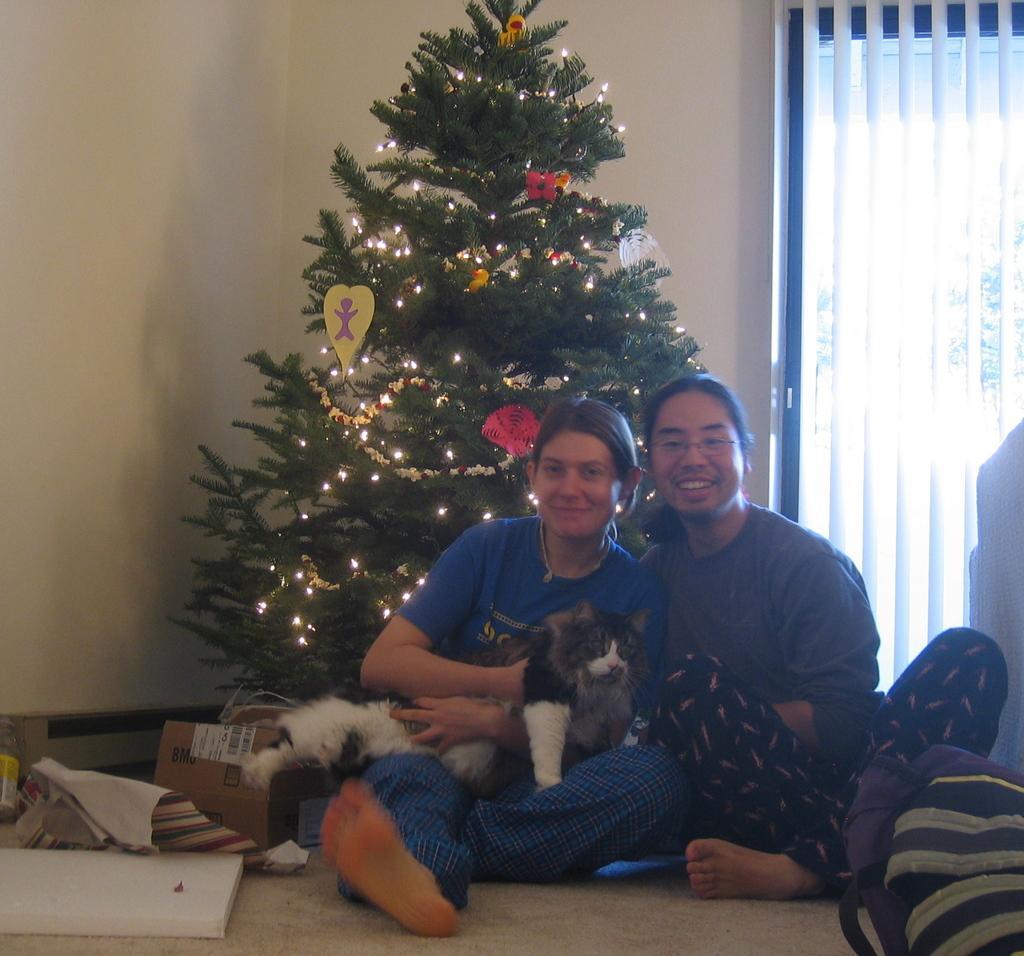Can you describe this image briefly? In this image there are two people sitting and one person is holding a dog, and at the bottom there is floor. On the floor there are some boxes, clothes, board and some objects. And in the background there is a christmas tree, window and wall. 